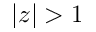<formula> <loc_0><loc_0><loc_500><loc_500>| z | > 1</formula> 